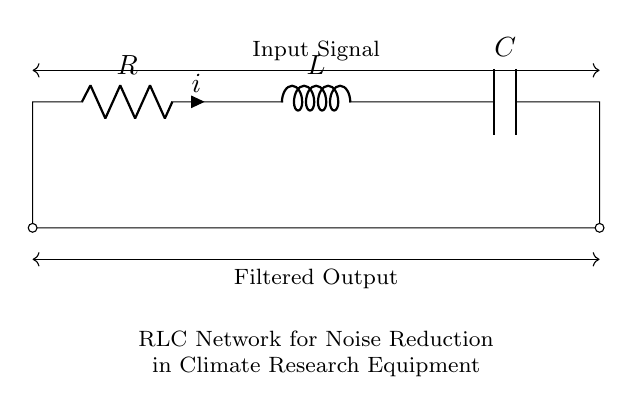What components are present in the circuit? The circuit contains a resistor, an inductor, and a capacitor, as indicated by the labels in the diagram.
Answer: Resistor, Inductor, Capacitor What is the purpose of the RLC network? The RLC network is designed for noise reduction in climate research equipment, as stated below the circuit diagram.
Answer: Noise reduction What type of circuit topology is this? The circuit is a series configuration, where the components are connected end-to-end with the same current flowing through all.
Answer: Series How many components are in the circuit? There are three components: a resistor, an inductor, and a capacitor, explicitly mentioned in the circuit.
Answer: Three What does R stand for in the circuit? R stands for the resistor, which is the component representing resistance in the circuit.
Answer: Resistor How does this circuit filter signals? The combination of resistance, inductance, and capacitance creates a frequency-dependent filtering effect, allowing certain frequencies to pass while attenuating others.
Answer: Frequency-dependent filtering What would happen if one of the components is removed? Removing any component would disrupt the resonance and filtering capability of the circuit, affecting its noise reduction performance.
Answer: Disruption of performance 